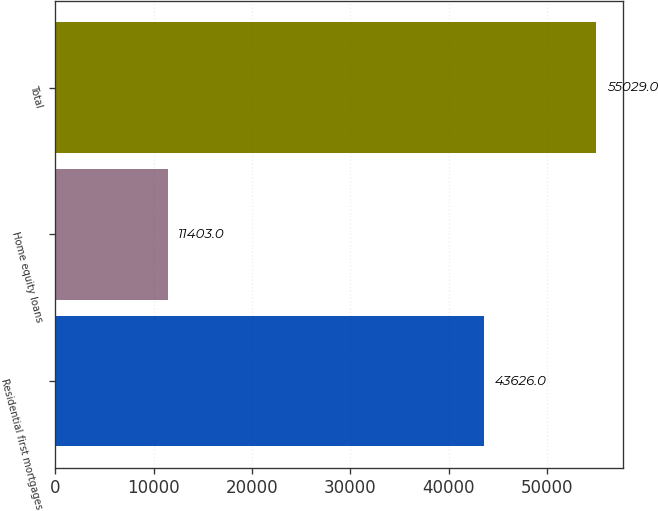<chart> <loc_0><loc_0><loc_500><loc_500><bar_chart><fcel>Residential first mortgages<fcel>Home equity loans<fcel>Total<nl><fcel>43626<fcel>11403<fcel>55029<nl></chart> 